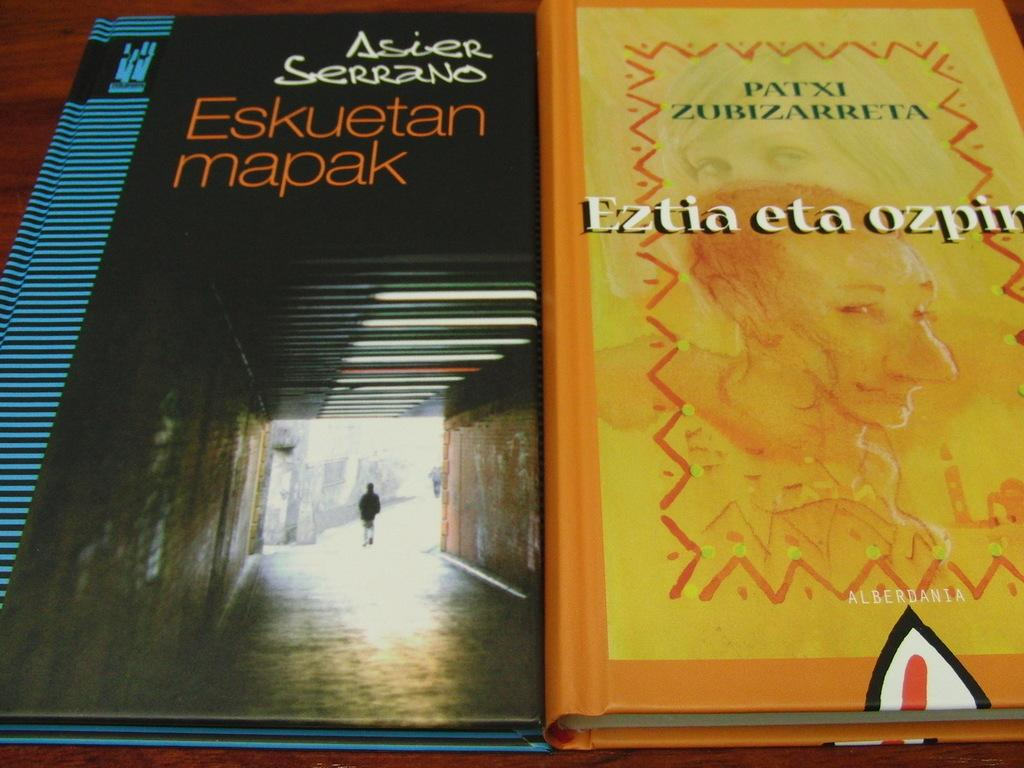<image>
Provide a brief description of the given image. Two books, one titled Eskuetan mapak, sit side by side. 